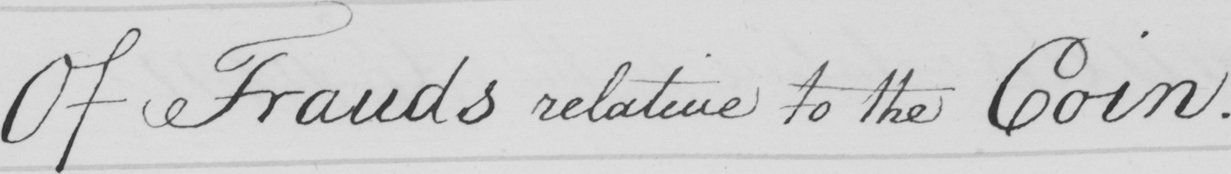Can you tell me what this handwritten text says? Of Frauds relative to the Coin . Reasons 